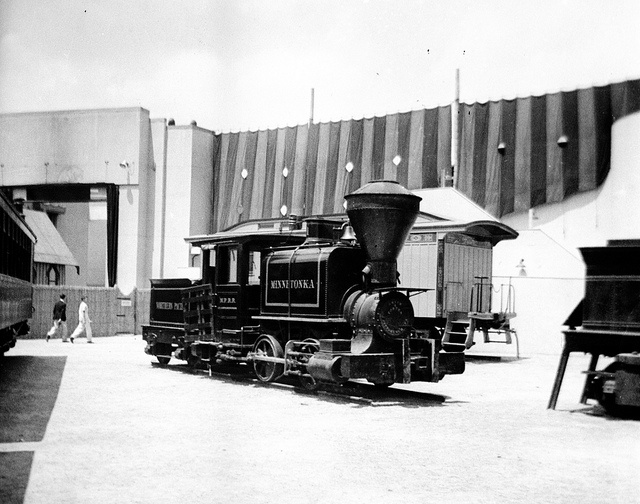Describe the objects in this image and their specific colors. I can see train in darkgray, black, gray, and lightgray tones, train in darkgray, black, gray, and lightgray tones, people in darkgray, black, gray, and lightgray tones, and people in darkgray, lightgray, gray, and black tones in this image. 